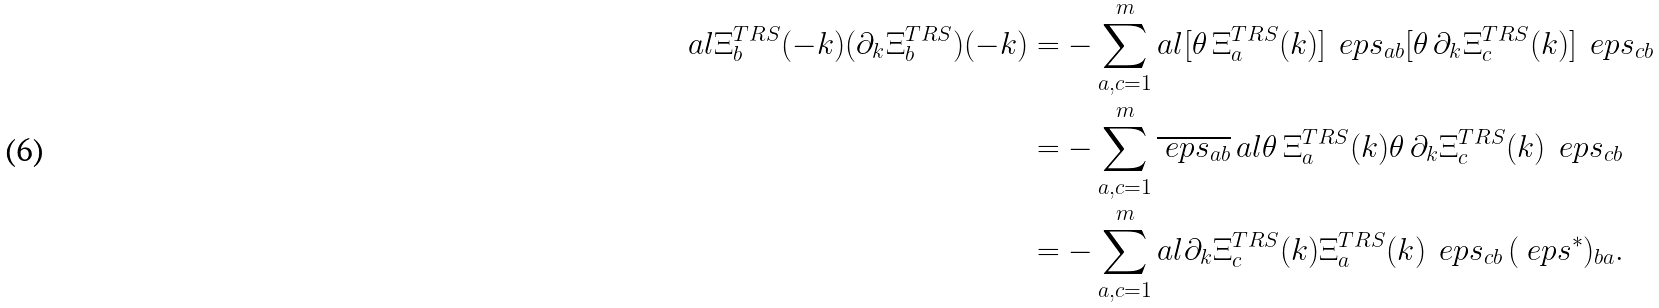Convert formula to latex. <formula><loc_0><loc_0><loc_500><loc_500>a l { \Xi ^ { T R S } _ { b } ( - k ) } { ( \partial _ { k } \Xi ^ { T R S } _ { b } ) ( - k ) } & = - \sum _ { a , c = 1 } ^ { m } a l { [ \theta \, \Xi ^ { T R S } _ { a } ( k ) ] \, \ e p s _ { a b } } { [ \theta \, \partial _ { k } \Xi ^ { T R S } _ { c } ( k ) ] \, \ e p s _ { c b } } \\ & = - \sum _ { a , c = 1 } ^ { m } \overline { \ e p s _ { a b } } \, a l { \theta \, \Xi ^ { T R S } _ { a } ( k ) } { \theta \, \partial _ { k } \Xi ^ { T R S } _ { c } ( k ) } \, \ e p s _ { c b } \\ & = - \sum _ { a , c = 1 } ^ { m } a l { \partial _ { k } \Xi ^ { T R S } _ { c } ( k ) } { \Xi ^ { T R S } _ { a } ( k ) } \, \ e p s _ { c b } \, ( \ e p s ^ { * } ) _ { b a } .</formula> 